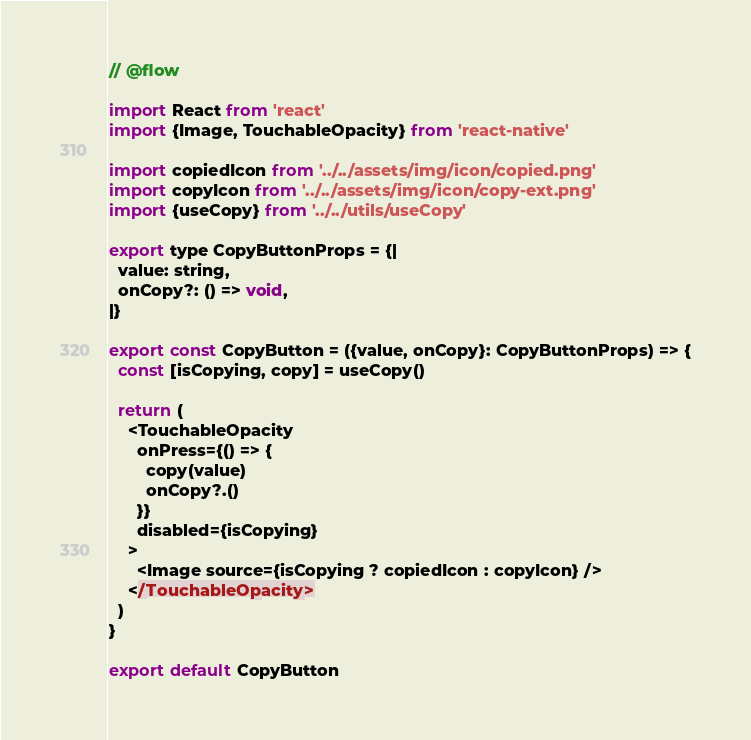<code> <loc_0><loc_0><loc_500><loc_500><_JavaScript_>// @flow

import React from 'react'
import {Image, TouchableOpacity} from 'react-native'

import copiedIcon from '../../assets/img/icon/copied.png'
import copyIcon from '../../assets/img/icon/copy-ext.png'
import {useCopy} from '../../utils/useCopy'

export type CopyButtonProps = {|
  value: string,
  onCopy?: () => void,
|}

export const CopyButton = ({value, onCopy}: CopyButtonProps) => {
  const [isCopying, copy] = useCopy()

  return (
    <TouchableOpacity
      onPress={() => {
        copy(value)
        onCopy?.()
      }}
      disabled={isCopying}
    >
      <Image source={isCopying ? copiedIcon : copyIcon} />
    </TouchableOpacity>
  )
}

export default CopyButton
</code> 